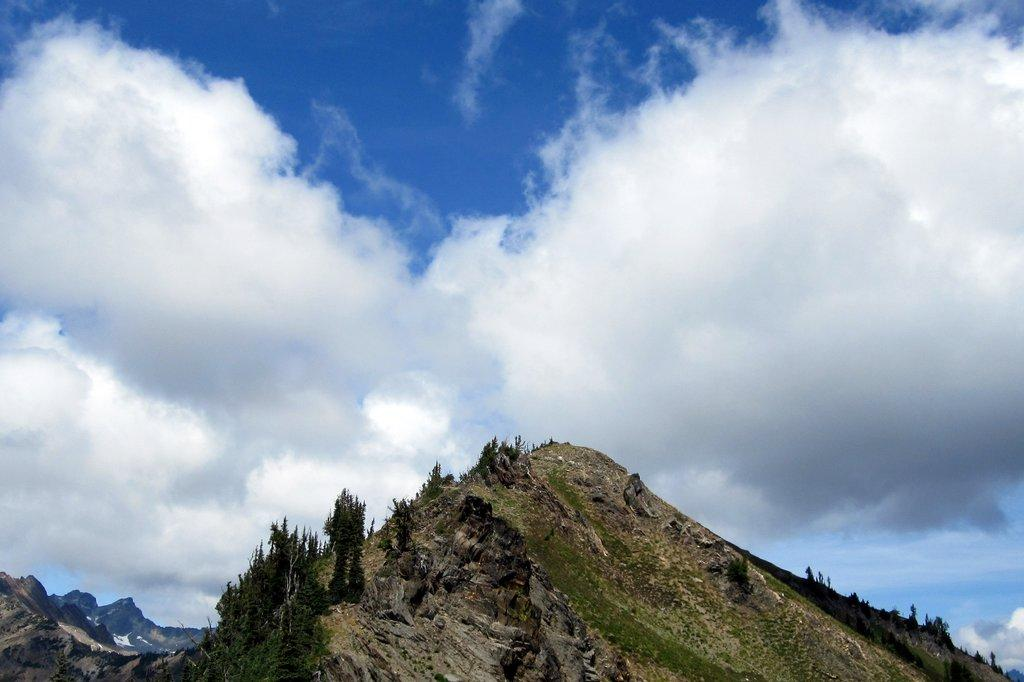What type of natural formation can be seen in the image? There are mountains in the image. What is present on the mountains? There are trees on the mountains. What is visible in the background of the image? The sky is visible in the background of the image. How would you describe the sky in the image? The sky is cloudy in the image. What type of cart is being used for the distribution of regret in the image? There is no cart or distribution of regret present in the image; it features mountains with trees and a cloudy sky. 